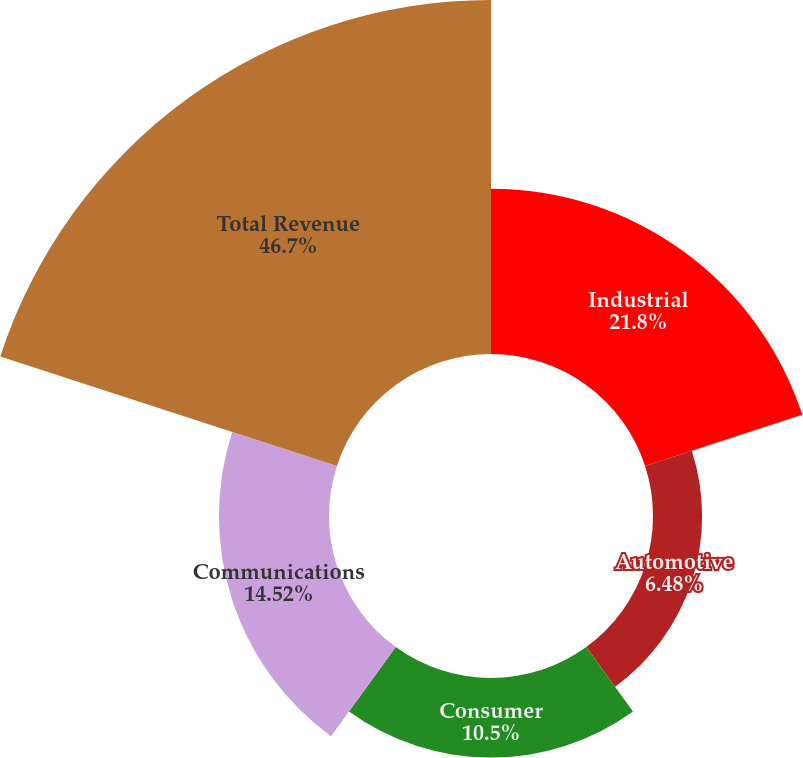Convert chart to OTSL. <chart><loc_0><loc_0><loc_500><loc_500><pie_chart><fcel>Industrial<fcel>Automotive<fcel>Consumer<fcel>Communications<fcel>Total Revenue<nl><fcel>21.8%<fcel>6.48%<fcel>10.5%<fcel>14.52%<fcel>46.69%<nl></chart> 